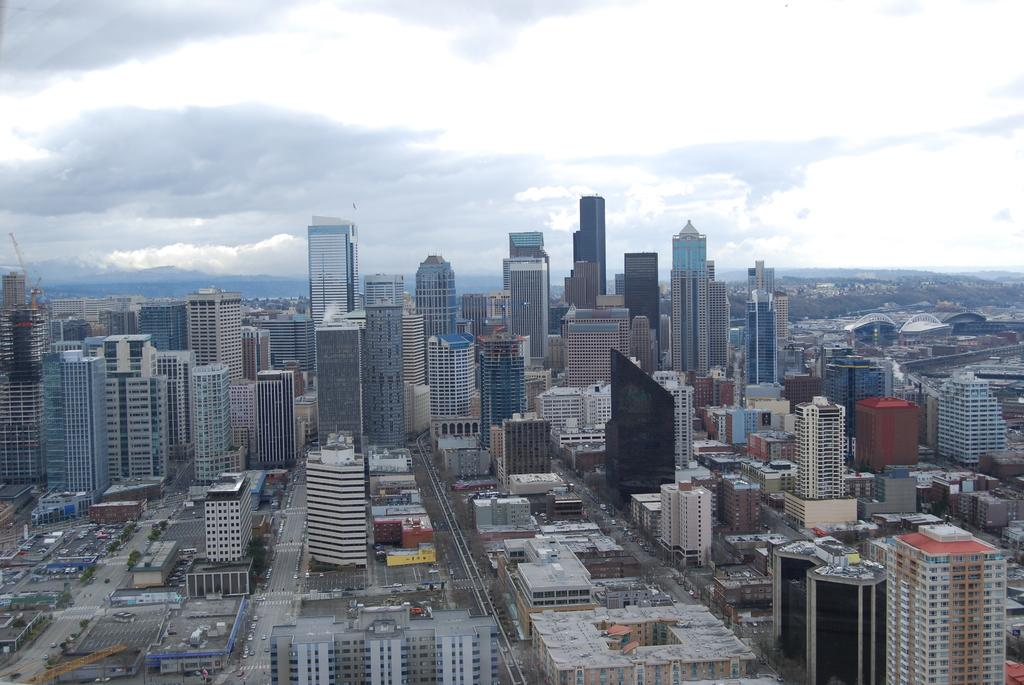What type of structures can be seen in the image? There are buildings in the image. What else can be seen on the ground in the image? There are roads and vehicles in the image. What type of vegetation is present in the image? There are trees in the image. What is visible in the background of the image? The sky is visible in the background of the image, and clouds are present in the sky. Where is the hole located in the image? There is no hole present in the image. What type of store can be seen in the image? There is no store present in the image. 